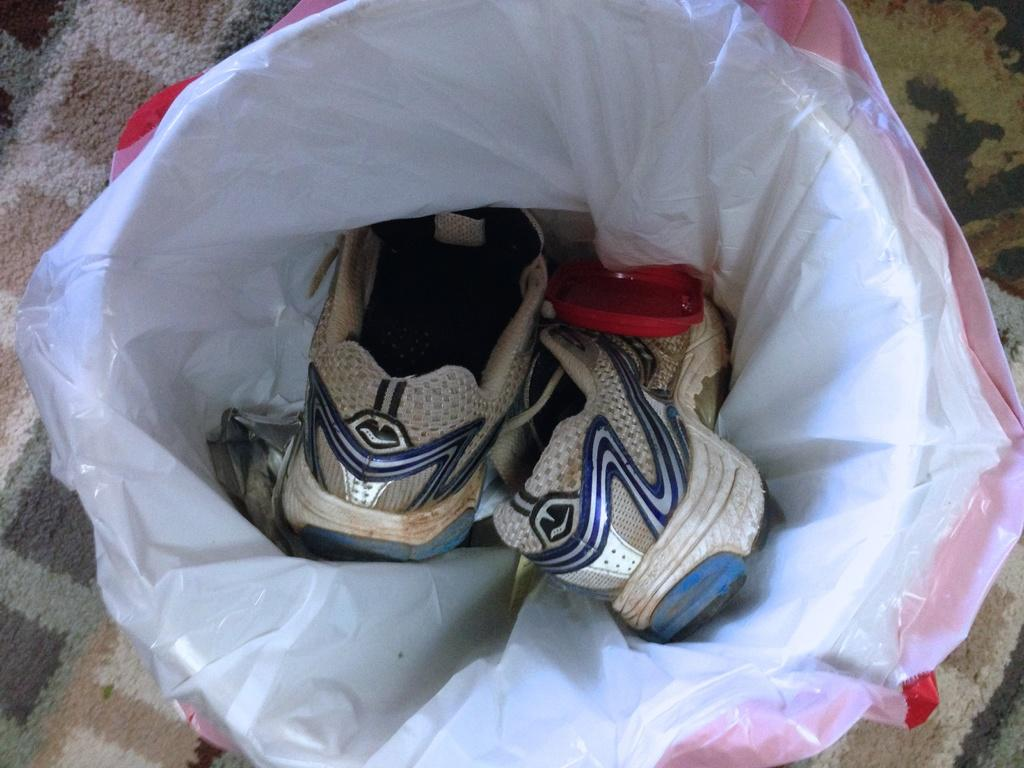What can be seen in the image related to footwear? There is a pair of shoes in the image. How are the shoes being protected or stored? The shoes are covered with a cover. What is visible in the background of the image? There is a mat in the background of the image. How many pigs are visible in the image? There are no pigs present in the image. Is the earth visible in the image? The image does not show the earth as a planet or geographical location; it features a pair of shoes with a cover and a mat in the background. 